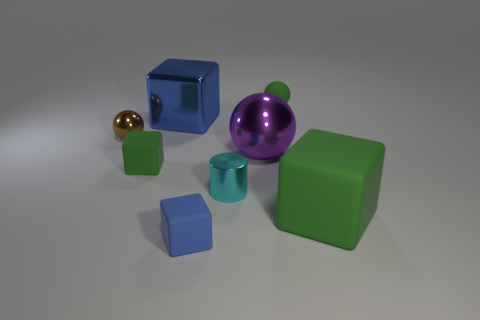Subtract all purple cubes. Subtract all brown cylinders. How many cubes are left? 4 Add 2 blue rubber things. How many objects exist? 10 Subtract all cylinders. How many objects are left? 7 Subtract all small spheres. Subtract all small blue matte objects. How many objects are left? 5 Add 3 brown balls. How many brown balls are left? 4 Add 5 small green rubber balls. How many small green rubber balls exist? 6 Subtract 0 yellow cylinders. How many objects are left? 8 